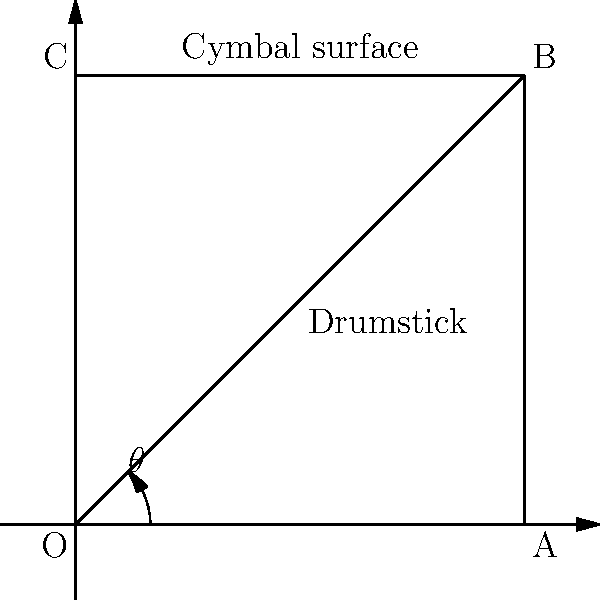As a percussionist, you're experimenting with cymbal sounds. You've noticed that the angle at which you strike the cymbal affects its timbre. If you want to produce a bright, cutting sound, what is the optimal angle $\theta$ (in degrees) between the drumstick and the cymbal surface? To determine the optimal angle for producing a bright, cutting sound on a cymbal, we need to consider the following factors:

1. Sound production in cymbals:
   - Cymbals produce sound through vibration when struck.
   - The initial impact and the subsequent oscillations contribute to the overall sound.

2. Effect of striking angle:
   - A more direct (perpendicular) strike transfers more energy to the cymbal.
   - This results in a brighter, more intense sound with more high-frequency content.

3. Optimal angle for bright sound:
   - The brightest and most cutting sound is typically produced when the strike is nearly perpendicular to the cymbal surface.
   - However, a completely perpendicular strike (90°) can be too harsh and may damage the cymbal.

4. Balancing factors:
   - We want an angle close to 90° for brightness, but slightly less to maintain control and protect the instrument.
   - Most professional percussionists recommend an angle between 80° and 85° for this type of sound.

5. Specific angle:
   - For this question, we'll choose 85° as the optimal angle.
   - This angle provides a very direct strike for a bright sound while still allowing for some glancing motion to protect the cymbal.

Therefore, the optimal angle $\theta$ between the drumstick and the cymbal surface for a bright, cutting sound is approximately 85°.
Answer: 85° 